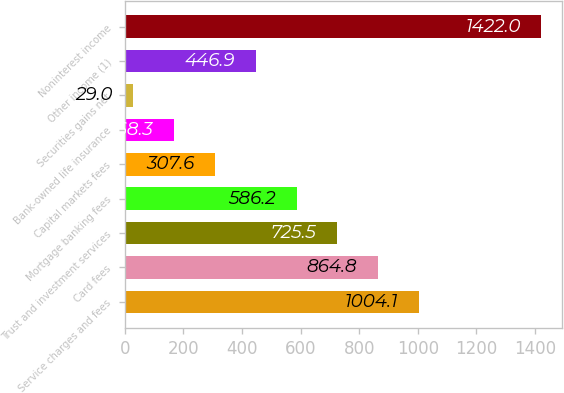Convert chart to OTSL. <chart><loc_0><loc_0><loc_500><loc_500><bar_chart><fcel>Service charges and fees<fcel>Card fees<fcel>Trust and investment services<fcel>Mortgage banking fees<fcel>Capital markets fees<fcel>Bank-owned life insurance<fcel>Securities gains net<fcel>Other income (1)<fcel>Noninterest income<nl><fcel>1004.1<fcel>864.8<fcel>725.5<fcel>586.2<fcel>307.6<fcel>168.3<fcel>29<fcel>446.9<fcel>1422<nl></chart> 